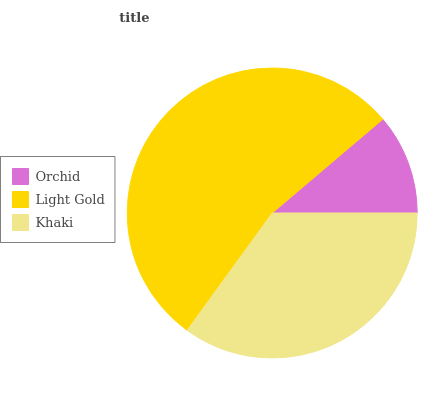Is Orchid the minimum?
Answer yes or no. Yes. Is Light Gold the maximum?
Answer yes or no. Yes. Is Khaki the minimum?
Answer yes or no. No. Is Khaki the maximum?
Answer yes or no. No. Is Light Gold greater than Khaki?
Answer yes or no. Yes. Is Khaki less than Light Gold?
Answer yes or no. Yes. Is Khaki greater than Light Gold?
Answer yes or no. No. Is Light Gold less than Khaki?
Answer yes or no. No. Is Khaki the high median?
Answer yes or no. Yes. Is Khaki the low median?
Answer yes or no. Yes. Is Light Gold the high median?
Answer yes or no. No. Is Orchid the low median?
Answer yes or no. No. 